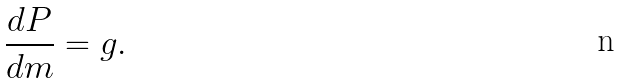<formula> <loc_0><loc_0><loc_500><loc_500>\frac { d P } { d m } = g .</formula> 